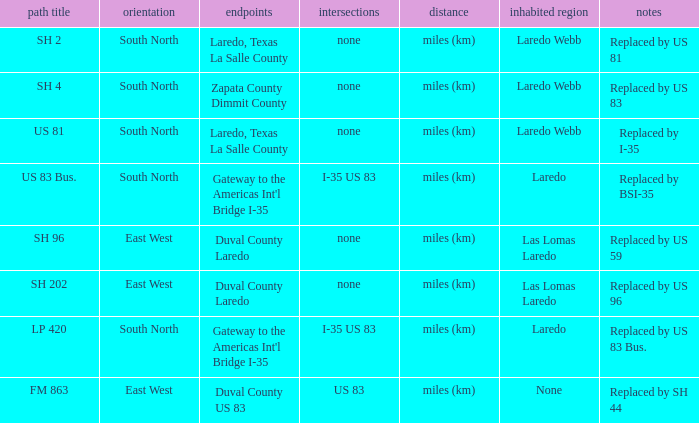Which routes have  "replaced by US 81" listed in their remarks section? SH 2. Parse the full table. {'header': ['path title', 'orientation', 'endpoints', 'intersections', 'distance', 'inhabited region', 'notes'], 'rows': [['SH 2', 'South North', 'Laredo, Texas La Salle County', 'none', 'miles (km)', 'Laredo Webb', 'Replaced by US 81'], ['SH 4', 'South North', 'Zapata County Dimmit County', 'none', 'miles (km)', 'Laredo Webb', 'Replaced by US 83'], ['US 81', 'South North', 'Laredo, Texas La Salle County', 'none', 'miles (km)', 'Laredo Webb', 'Replaced by I-35'], ['US 83 Bus.', 'South North', "Gateway to the Americas Int'l Bridge I-35", 'I-35 US 83', 'miles (km)', 'Laredo', 'Replaced by BSI-35'], ['SH 96', 'East West', 'Duval County Laredo', 'none', 'miles (km)', 'Las Lomas Laredo', 'Replaced by US 59'], ['SH 202', 'East West', 'Duval County Laredo', 'none', 'miles (km)', 'Las Lomas Laredo', 'Replaced by US 96'], ['LP 420', 'South North', "Gateway to the Americas Int'l Bridge I-35", 'I-35 US 83', 'miles (km)', 'Laredo', 'Replaced by US 83 Bus.'], ['FM 863', 'East West', 'Duval County US 83', 'US 83', 'miles (km)', 'None', 'Replaced by SH 44']]} 